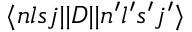<formula> <loc_0><loc_0><loc_500><loc_500>\langle n l s j | | D | | n ^ { \prime } l ^ { \prime } s ^ { \prime } j ^ { \prime } \rangle</formula> 